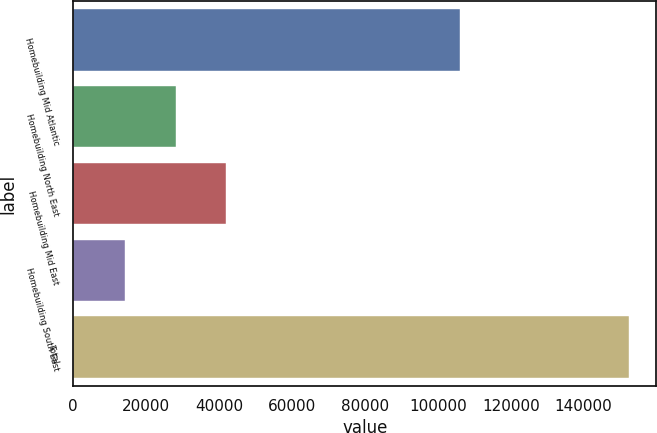Convert chart. <chart><loc_0><loc_0><loc_500><loc_500><bar_chart><fcel>Homebuilding Mid Atlantic<fcel>Homebuilding North East<fcel>Homebuilding Mid East<fcel>Homebuilding South East<fcel>Total<nl><fcel>106032<fcel>28089.2<fcel>41897.4<fcel>14281<fcel>152363<nl></chart> 